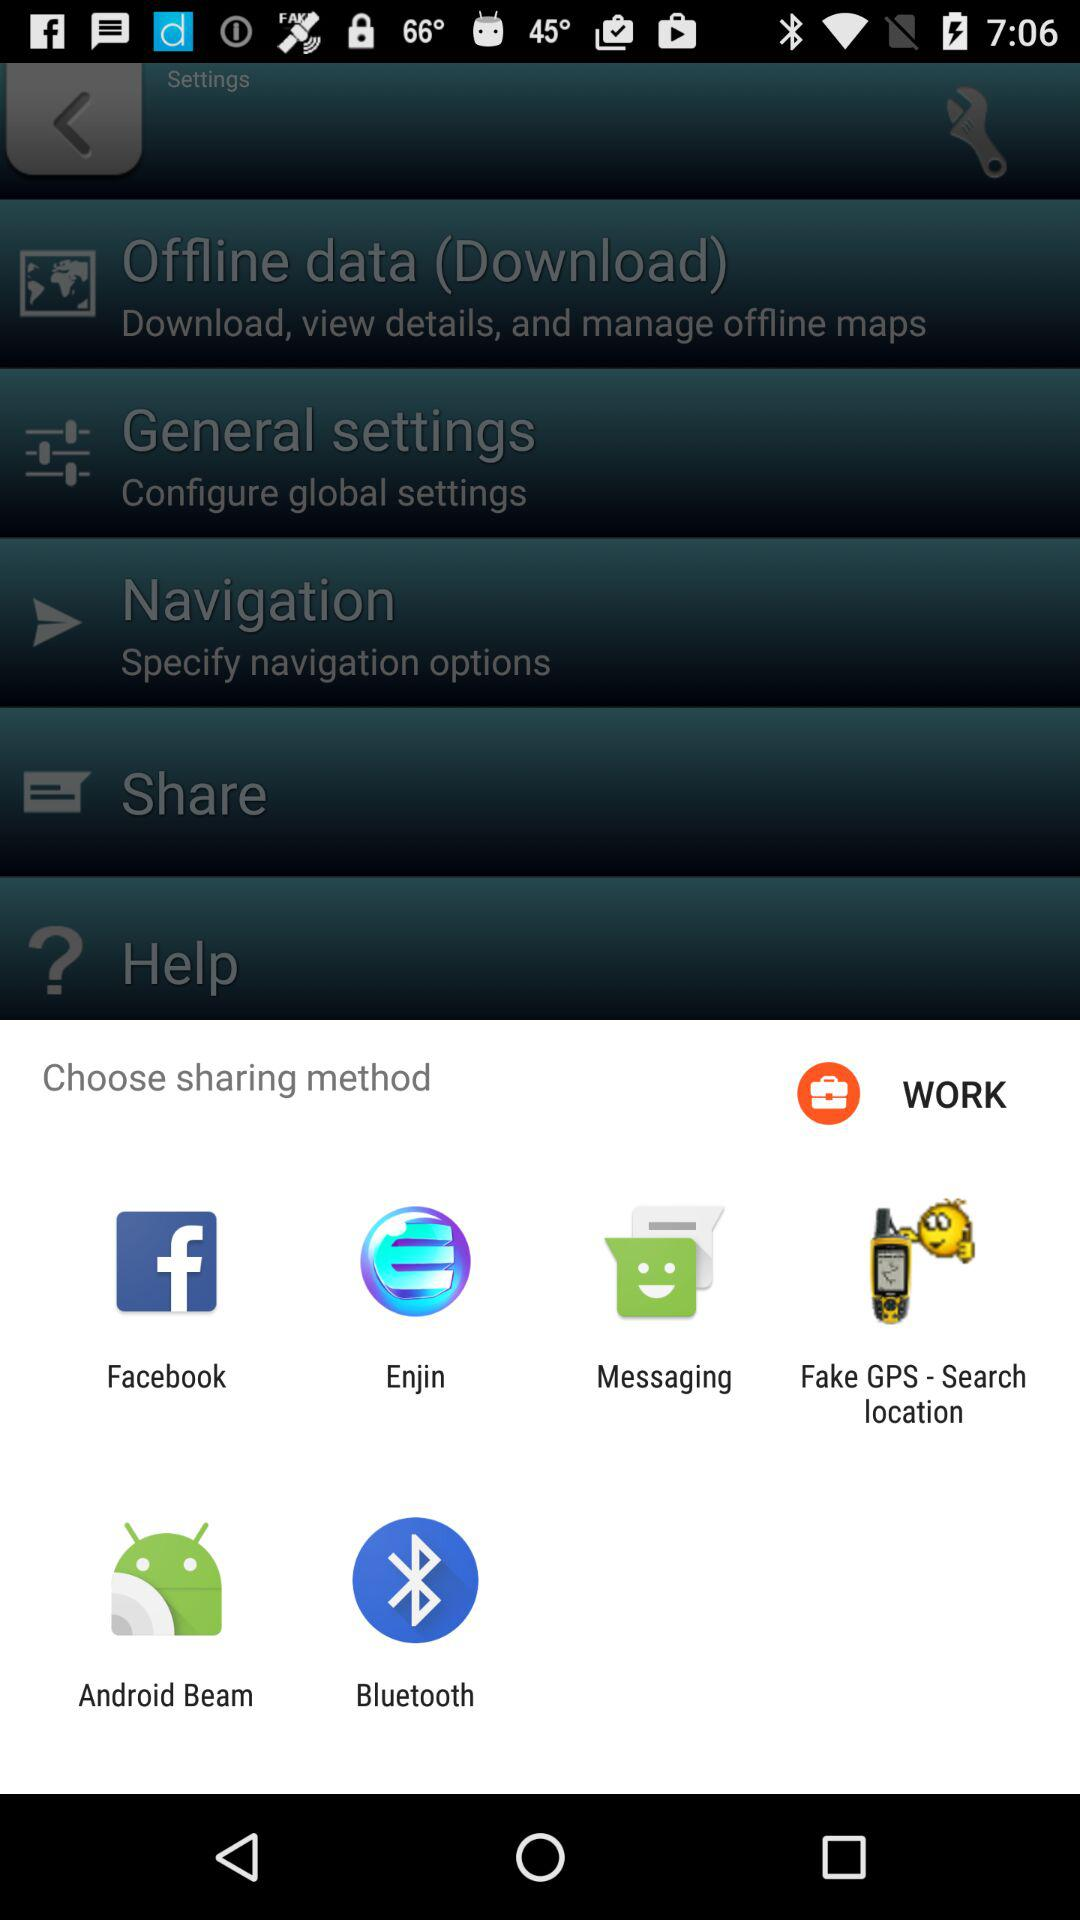Which application can we choose to share? You can choose "Facebook", "Enjin", "Messaging", "Fake GPS - Search location", "Android Beam" and "Bluetooth" to share. 